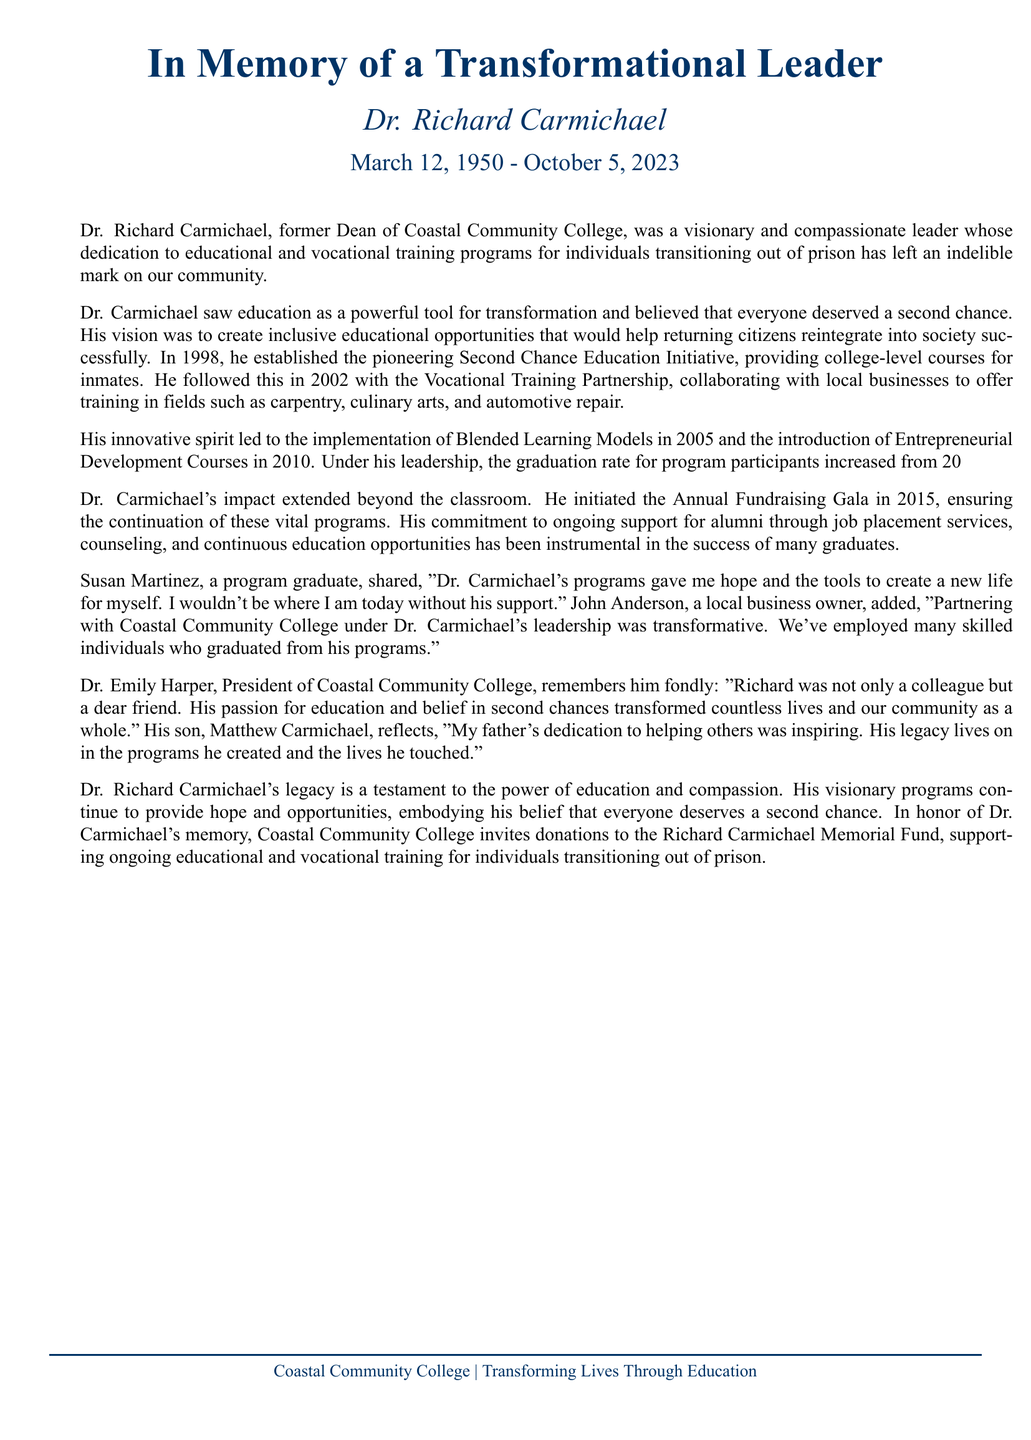What was Dr. Richard Carmichael's role? Dr. Richard Carmichael was the former Dean of Coastal Community College, as mentioned in the document.
Answer: former Dean When was the Second Chance Education Initiative established? The document states that the Second Chance Education Initiative was established in 1998.
Answer: 1998 What percentage did the graduation rate increase to under Dr. Carmichael's leadership? The document mentions that the graduation rate increased from 20% to 65%.
Answer: 65% Who shared a quote about the impact of Dr. Carmichael's programs? The document includes a quote from Susan Martinez, a program graduate.
Answer: Susan Martinez What was Dr. Carmichael's belief regarding education? The document states that he believed education was a powerful tool for transformation.
Answer: powerful tool for transformation In which year did the Annual Fundraising Gala start? The text specifies that the Annual Fundraising Gala was initiated in 2015.
Answer: 2015 What type of courses were introduced in 2010? According to the document, Entrepreneurial Development Courses were introduced in 2010.
Answer: Entrepreneurial Development Courses How did Dr. Emily Harper describe her relationship with Dr. Carmichael? The document states that Dr. Emily Harper remembered him as not only a colleague but a dear friend.
Answer: dear friend What is the purpose of the Richard Carmichael Memorial Fund? The document indicates that the fund supports ongoing educational and vocational training for individuals transitioning out of prison.
Answer: ongoing educational and vocational training 